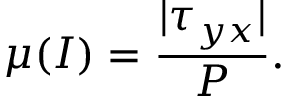<formula> <loc_0><loc_0><loc_500><loc_500>\mu ( I ) = \frac { | \tau _ { y x } | } { P } .</formula> 